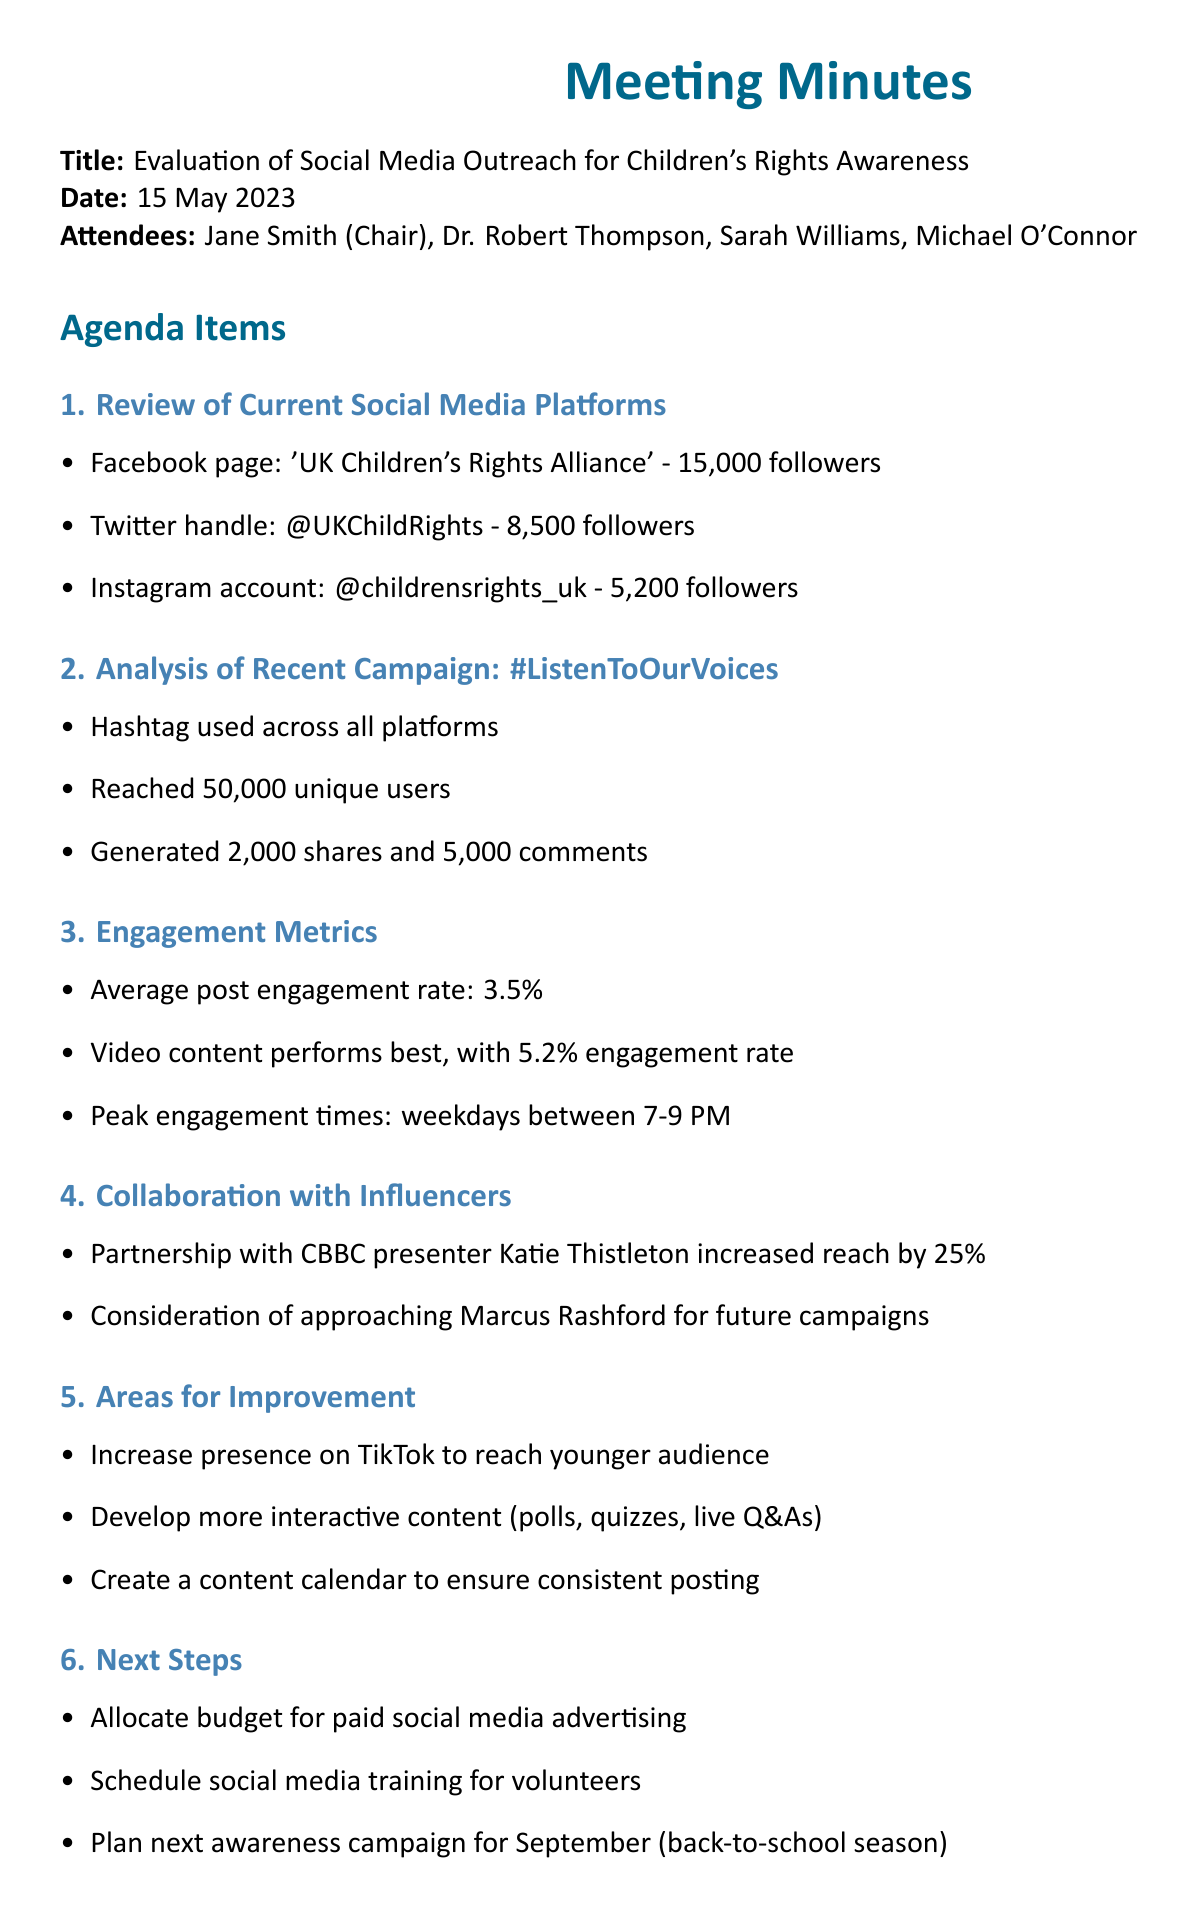What is the title of the meeting? The title of the meeting is stated at the top of the document.
Answer: Evaluation of Social Media Outreach for Children's Rights Awareness What was the date of the meeting? The date is clearly labeled in the document.
Answer: 15 May 2023 How many followers does the Facebook page have? Followers count for each social media platform is listed.
Answer: 15,000 followers What was the engagement rate for video content? Engagement metrics are provided for different types of content.
Answer: 5.2% Who increased reach by 25% through collaboration? The document mentions a specific influencer in relation to increased reach.
Answer: Katie Thistleton What percentage of post engagement is the average? The average post engagement rate is explicitly stated in the document.
Answer: 3.5% What is one area for improvement mentioned in the meeting? Areas for improvement are listed, providing specific suggestions.
Answer: Increase presence on TikTok What is the next planned awareness campaign's target month? The next steps section indicates when the next campaign will take place.
Answer: September How many unique users were reached by the campaign #ListenToOurVoices? The results of the recent campaign are summarized in the document.
Answer: 50,000 unique users 